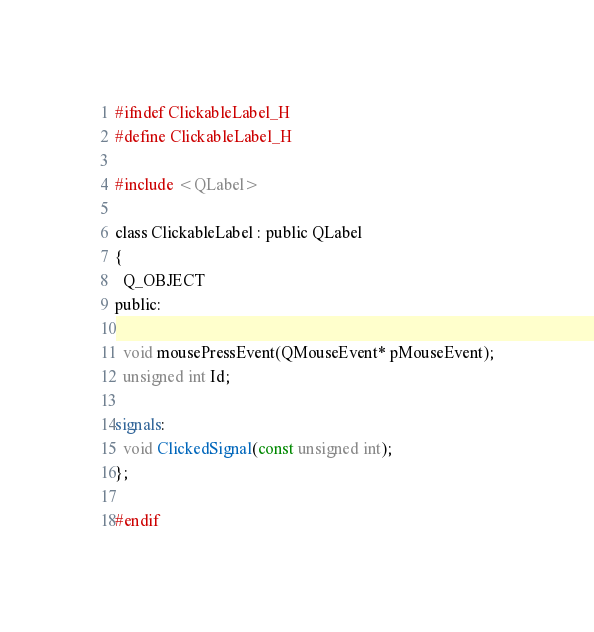<code> <loc_0><loc_0><loc_500><loc_500><_C_>#ifndef ClickableLabel_H
#define ClickableLabel_H

#include <QLabel>

class ClickableLabel : public QLabel
{
  Q_OBJECT
public:
  
  void mousePressEvent(QMouseEvent* pMouseEvent);
  unsigned int Id;

signals:
  void ClickedSignal(const unsigned int);
};

#endif
</code> 